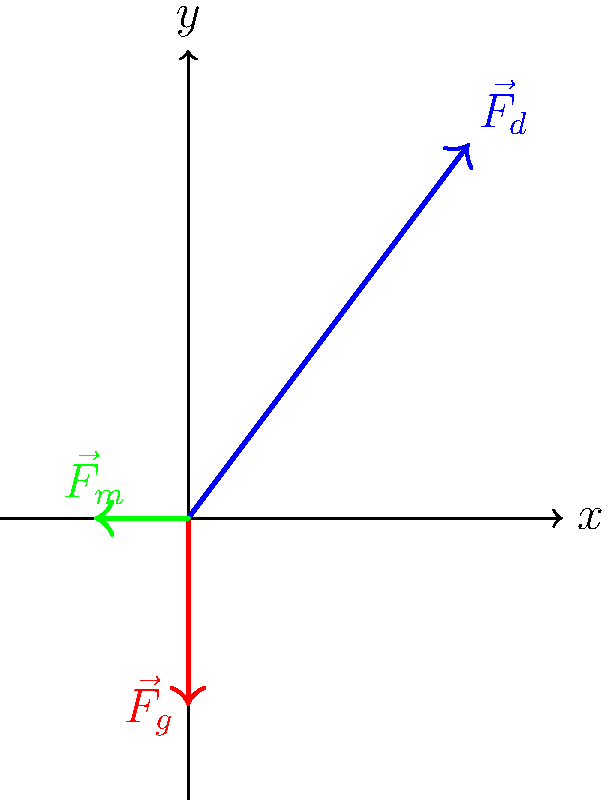During a historic home run hit by Jackie Robinson, three main forces act on the baseball: drag force ($\vec{F}_d$), gravitational force ($\vec{F}_g$), and Magnus force ($\vec{F}_m$). Given the vector diagram, which force contributes most significantly to the horizontal displacement of the ball, and what is its magnitude if the vectors are drawn to scale? To determine which force contributes most to the horizontal displacement and its magnitude, we'll follow these steps:

1. Identify the horizontal components of each force:
   - $\vec{F}_d$: Has a significant horizontal component (to the right)
   - $\vec{F}_g$: No horizontal component (purely vertical)
   - $\vec{F}_m$: Has a horizontal component (to the left)

2. Compare the horizontal components:
   - $\vec{F}_d$ has the largest horizontal component, pointing to the right
   - $\vec{F}_m$ has a smaller horizontal component, pointing to the left
   - $\vec{F}_g$ does not contribute to horizontal motion

3. Conclude that $\vec{F}_d$ (drag force) contributes most to the horizontal displacement

4. Calculate the magnitude of $\vec{F}_d$ using the Pythagorean theorem:
   - Horizontal component: 3 units
   - Vertical component: 4 units
   - Magnitude = $\sqrt{3^2 + 4^2} = \sqrt{9 + 16} = \sqrt{25} = 5$ units

Therefore, the drag force ($\vec{F}_d$) contributes most significantly to the horizontal displacement of the ball, with a magnitude of 5 units.
Answer: Drag force ($\vec{F}_d$), 5 units 